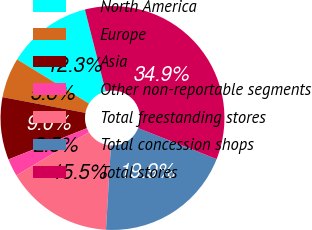Convert chart. <chart><loc_0><loc_0><loc_500><loc_500><pie_chart><fcel>North America<fcel>Europe<fcel>Asia<fcel>Other non-reportable segments<fcel>Total freestanding stores<fcel>Total concession shops<fcel>Total stores<nl><fcel>12.26%<fcel>5.78%<fcel>9.02%<fcel>2.54%<fcel>15.5%<fcel>19.94%<fcel>34.94%<nl></chart> 